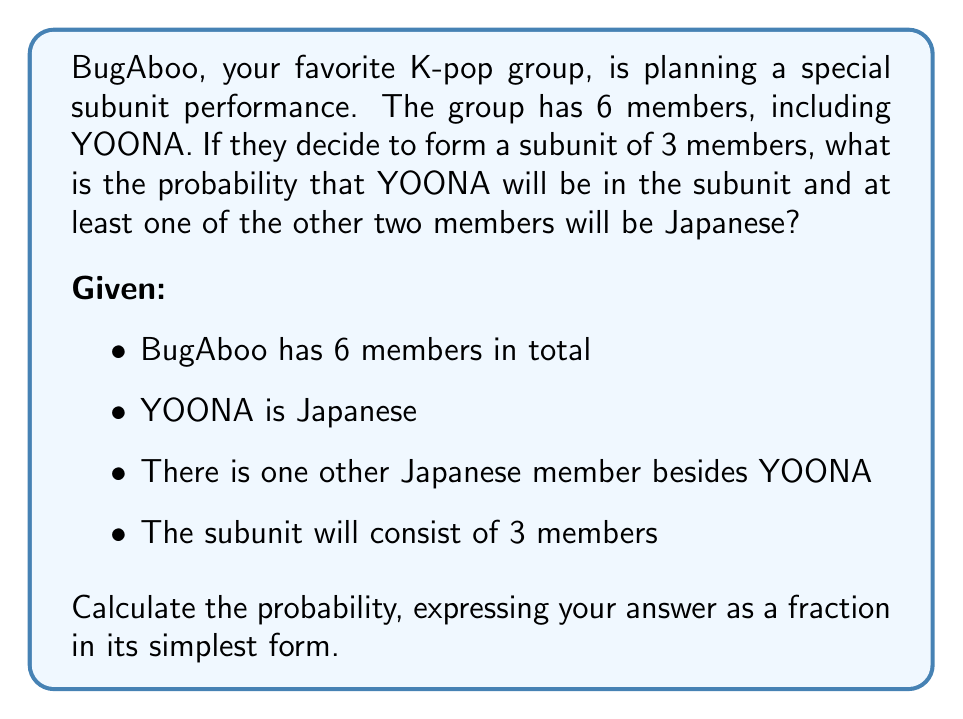Can you answer this question? Let's approach this step-by-step:

1) First, we know YOONA must be in the subunit. So we need to choose 2 more members from the remaining 5.

2) We have two scenarios to consider:
   a) 1 Japanese member (other than YOONA) and 1 non-Japanese member
   b) 1 Japanese member (other than YOONA) and 2 non-Japanese members

3) For scenario a):
   - We must choose the other Japanese member: $\binom{1}{1} = 1$ way
   - We must choose 1 from the 4 non-Japanese members: $\binom{4}{1} = 4$ ways
   - Total ways for this scenario: $1 \times 4 = 4$ ways

4) For scenario b):
   - We must choose the other Japanese member: $\binom{1}{1} = 1$ way
   - We must choose 2 from the 4 non-Japanese members: $\binom{4}{2} = 6$ ways
   - Total ways for this scenario: $1 \times 6 = 6$ ways

5) Total favorable outcomes: $4 + 6 = 10$ ways

6) Total possible outcomes (choosing 2 from 5 members): $\binom{5}{2} = 10$ ways

7) Therefore, the probability is:

   $$P(\text{YOONA and at least one other Japanese}) = \frac{\text{Favorable outcomes}}{\text{Total outcomes}} = \frac{10}{10} = 1$$
Answer: The probability is $1$ or $100\%$. 